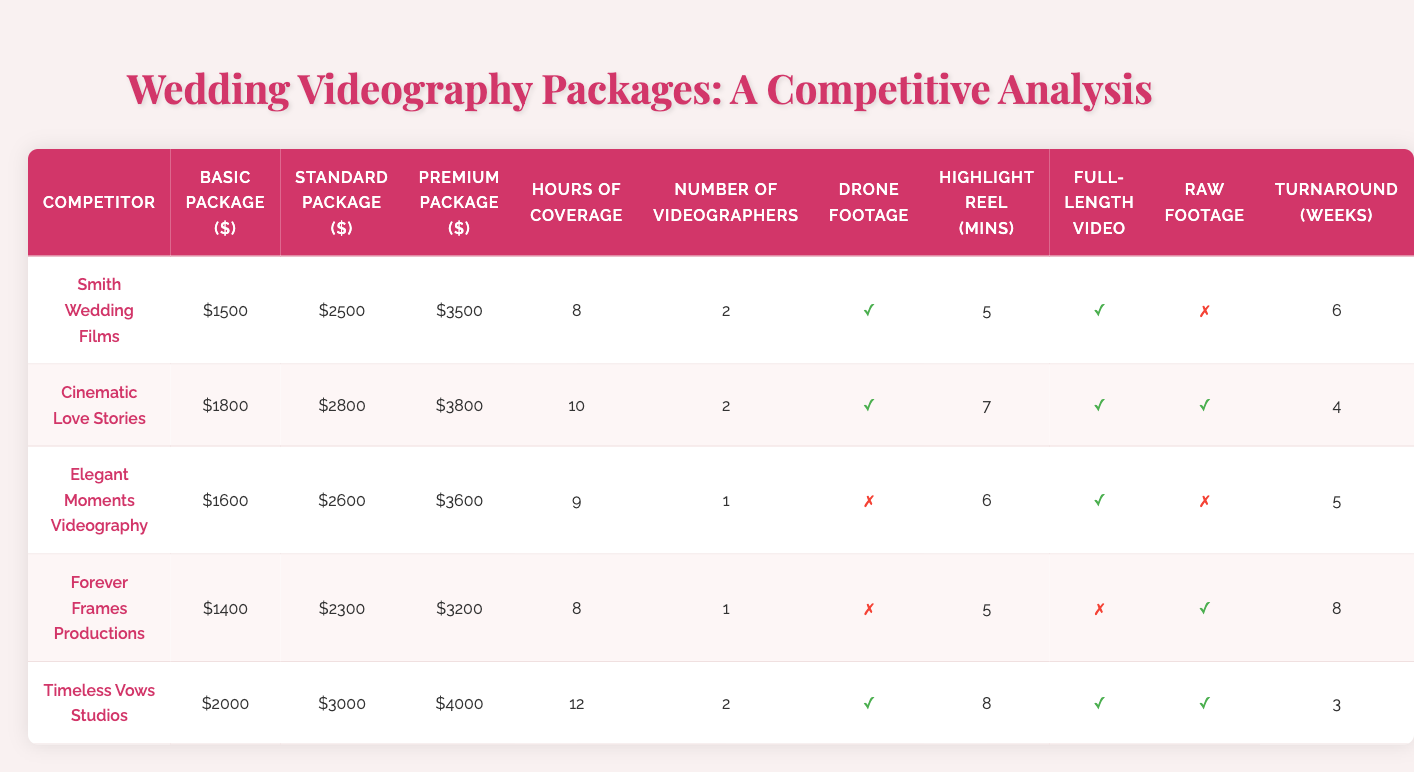What is the price of the Premium Package offered by Elegant Moments Videography? According to the table, the Premium Package price for Elegant Moments Videography is $3600.
Answer: $3600 Which competitor offers the lowest Basic Package price? The table shows that Forever Frames Productions offers the lowest Basic Package price at $1400.
Answer: Forever Frames Productions What is the turnaround time for the competitor that includes drone footage? Several competitors include drone footage: Smith Wedding Films (6 weeks), Cinematic Love Stories (4 weeks), and Timeless Vows Studios (3 weeks). The turnaround time for Timeless Vows Studios, which is the shortest, is 3 weeks.
Answer: 3 weeks How many competitors offer a full-length video as part of their packages? Looking at the "Full-Length Video Included" column, four competitors (Smith Wedding Films, Cinematic Love Stories, Elegant Moments Videography, and Timeless Vows Studios) offer a full-length video, while only Forever Frames Productions does not.
Answer: 4 What is the average price of the Standard Packages offered by all competitors? The Standard Package prices are $2500, $2800, $2600, $2300, and $3000. The average is calculated by summing these values ($2500 + $2800 + $2600 + $2300 + $3000 = $13200) and dividing by the number of competitors (5), resulting in an average of $2640.
Answer: $2640 Which competitor has the highest number of videographers and what is that number? The table shows that both Smith Wedding Films and Timeless Vows Studios have 2 videographers, which is the highest among competitors.
Answer: 2 Does any competitor provide raw footage for their packages? The table indicates that Cinematic Love Stories, Forever Frames Productions, and Timeless Vows Studios provide raw footage, while others do not.
Answer: Yes What is the difference in price between the Basic and Premium Packages for Timeless Vows Studios? Timeless Vows Studios charges $2000 for their Basic Package and $4000 for the Premium Package. The difference is calculated as $4000 - $2000 = $2000.
Answer: $2000 Which competitors offer the most hours of coverage and how many? The competitor with the most hours of coverage is Timeless Vows Studios with 12 hours. Smith Wedding Films, Cinematic Love Stories, and Elegant Moments Videography each offer less coverage at 8, 10, and 9 hours respectively.
Answer: 12 hours What percentage of the competitors include drone footage in their packages? Out of the five competitors, three include drone footage (Smith Wedding Films, Cinematic Love Stories, and Timeless Vows Studios). To find the percentage, divide by the total number of competitors: (3 / 5) * 100 = 60%.
Answer: 60% Does the competitor with the lowest Basic Package price also have the lowest Standard Package price? Forever Frames Productions has the lowest Basic Package price ($1400) but does not have the lowest Standard Package price ($2300) as that goes to Smith Wedding Films ($2500). Therefore, the competitor with the lowest Basic Package does not have the lowest Standard Package.
Answer: No 